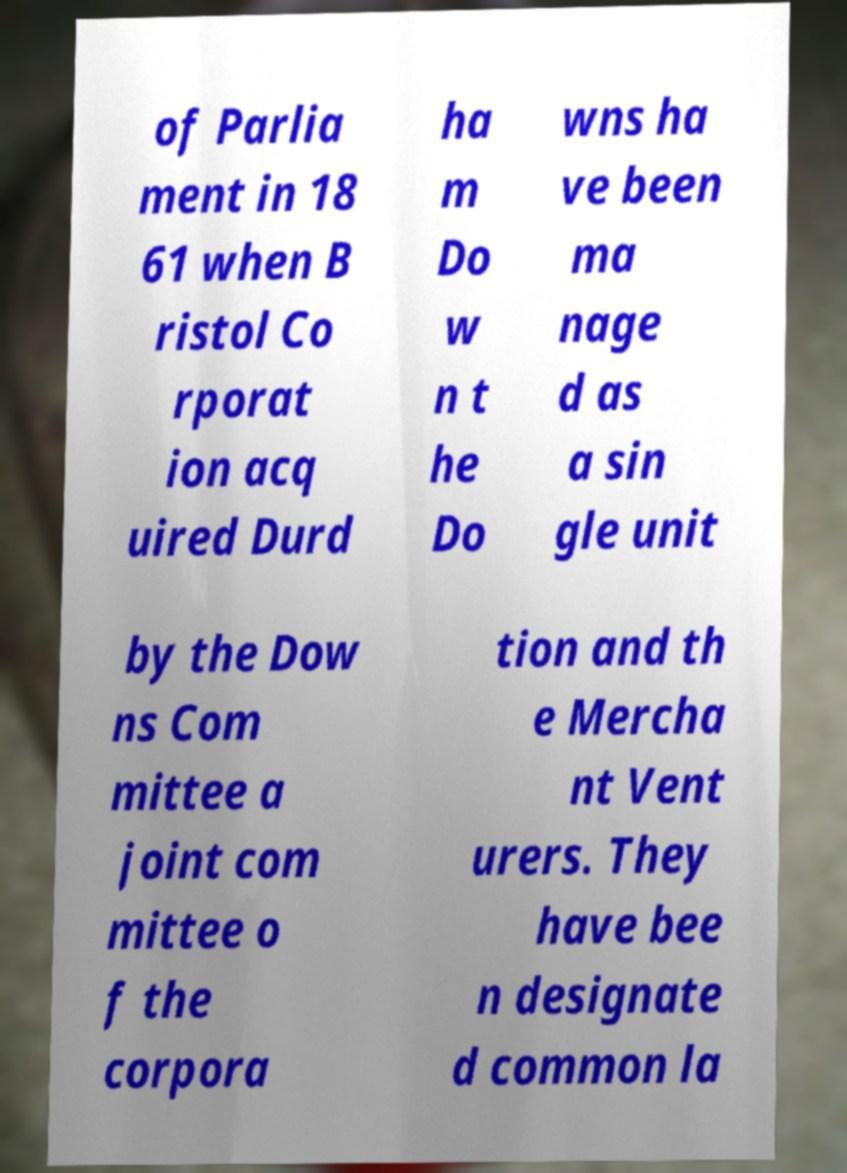I need the written content from this picture converted into text. Can you do that? of Parlia ment in 18 61 when B ristol Co rporat ion acq uired Durd ha m Do w n t he Do wns ha ve been ma nage d as a sin gle unit by the Dow ns Com mittee a joint com mittee o f the corpora tion and th e Mercha nt Vent urers. They have bee n designate d common la 